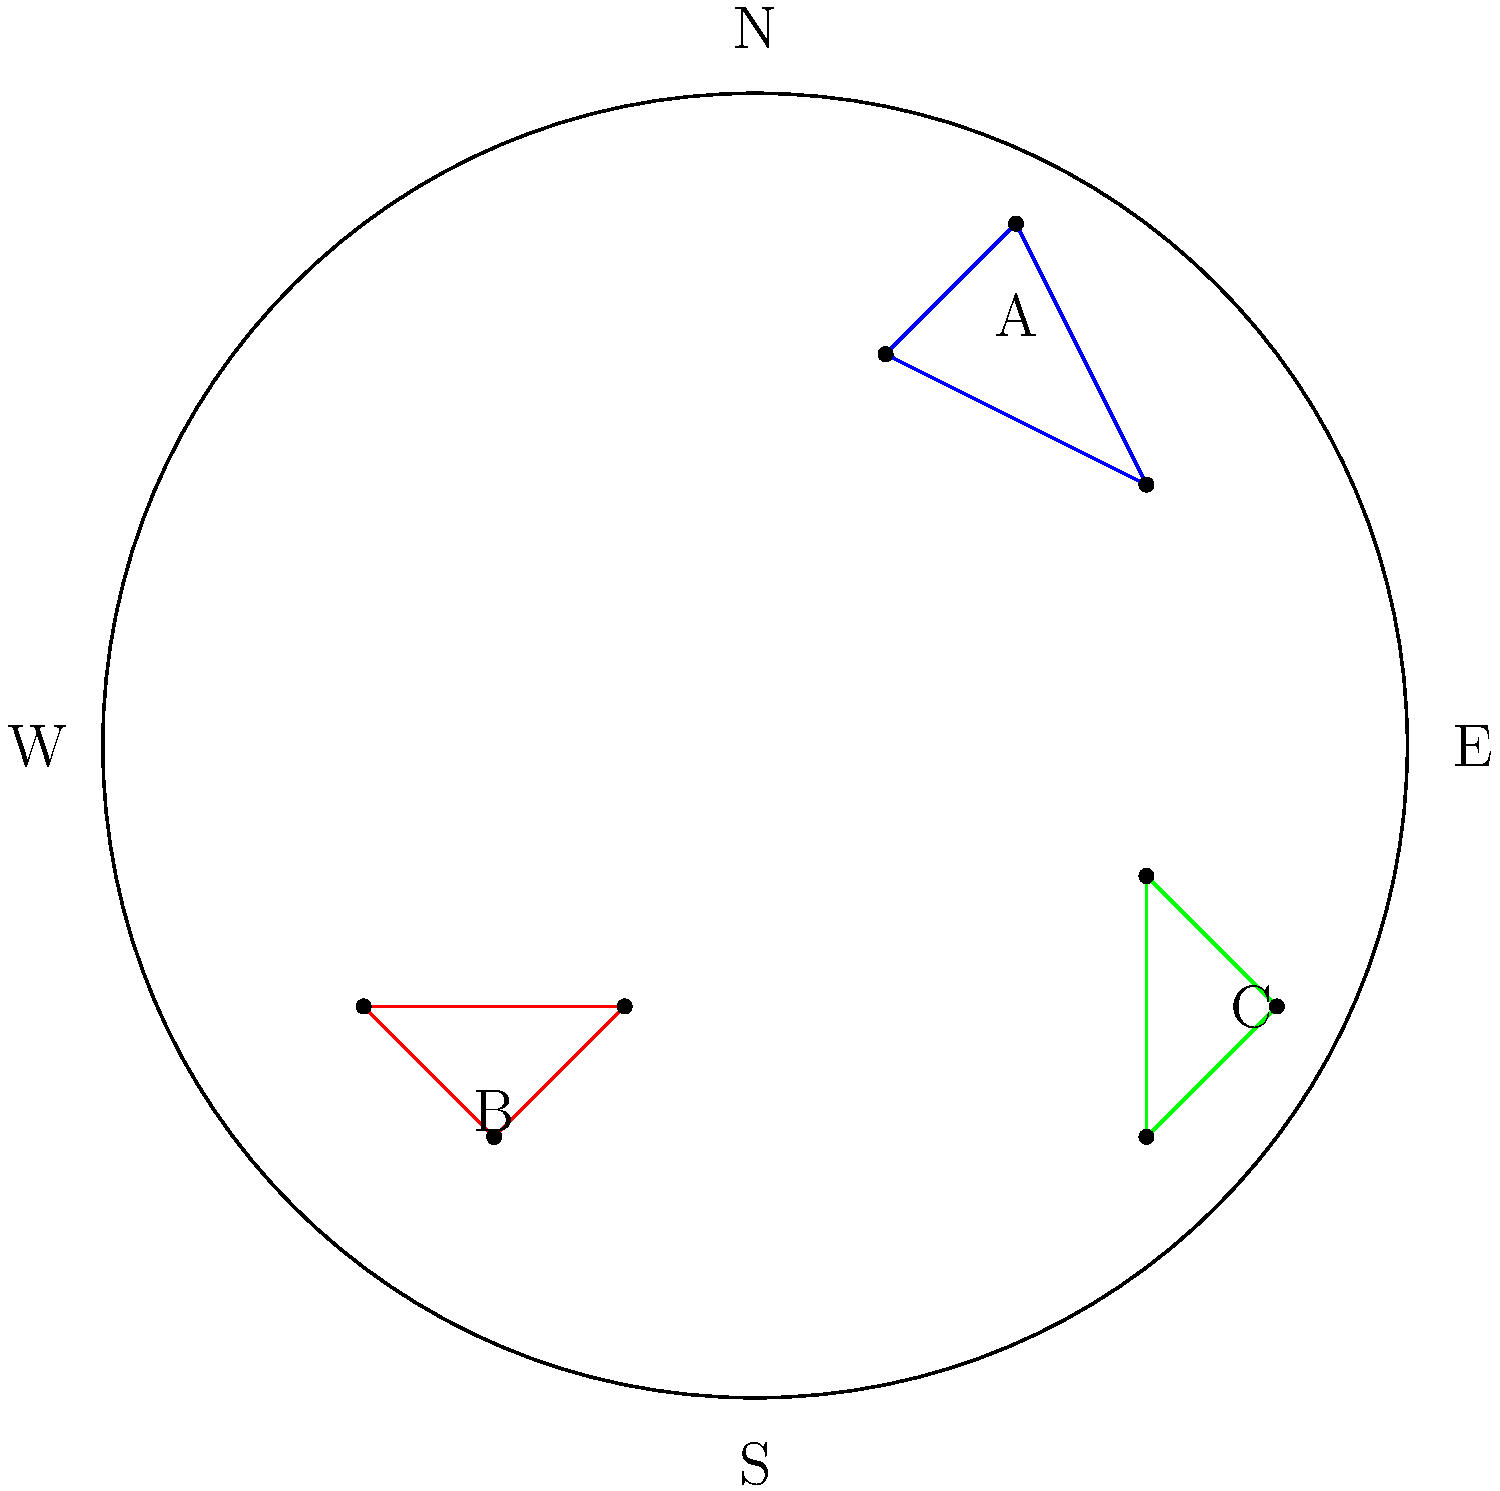Using the star chart provided, which constellation is located in the eastern part of the sky? To answer this question, we need to follow these steps:

1. Understand the orientation of the star chart:
   - The chart shows a view of the night sky.
   - Cardinal directions (N, S, E, W) are marked on the edges of the circular chart.

2. Locate the eastern direction:
   - East (E) is marked on the right side of the chart.

3. Identify the constellations:
   - There are three constellations shown, labeled A, B, and C.

4. Determine which constellation is in the eastern part:
   - Constellation A is towards the north.
   - Constellation B is towards the south.
   - Constellation C is towards the east.

5. Conclude:
   - The constellation located in the eastern part of the sky is C.

This question helps students understand how to read and interpret star charts, which is an important skill in astronomy and connects to the teacher's interest in local culture and history, as constellations often have cultural significance and historical stories associated with them.
Answer: C 